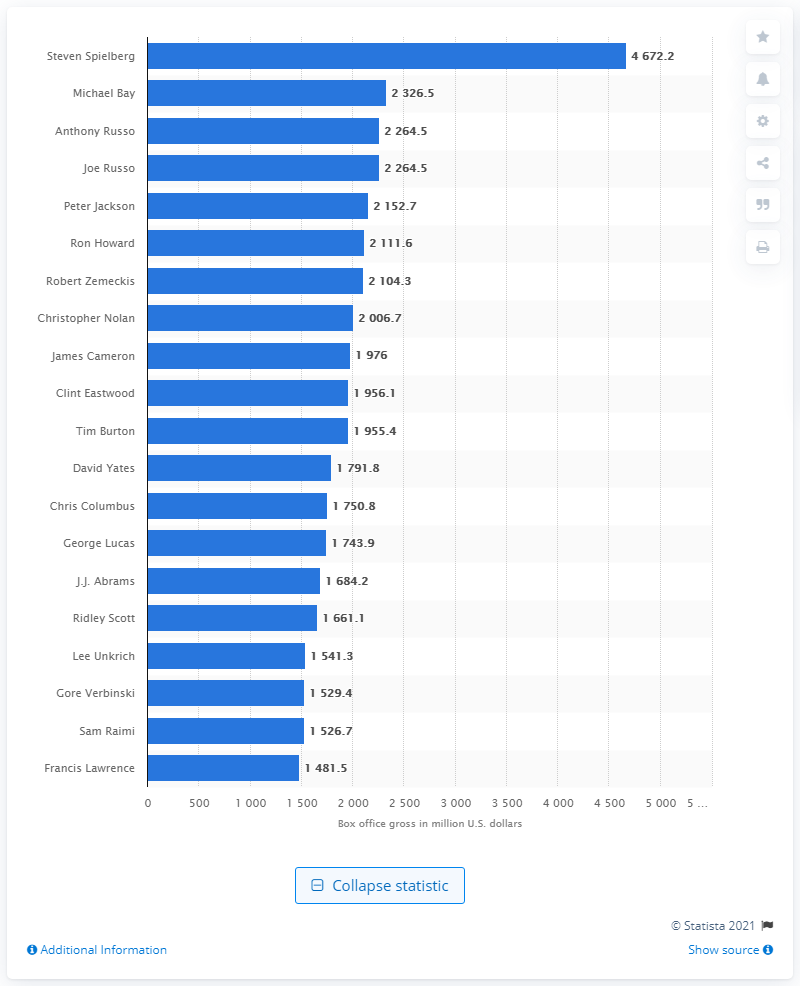Mention a couple of crucial points in this snapshot. The total amount of money made in the U.S. domestic box office by Steven Spielberg is 4672.2. The highest-grossing director of all time is Steven Spielberg, who has earned a significant amount of revenue through his successful movie productions. 